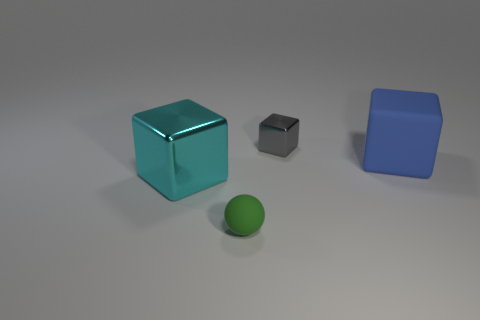Add 1 cyan blocks. How many objects exist? 5 Subtract all cubes. How many objects are left? 1 Add 1 big purple metallic things. How many big purple metallic things exist? 1 Subtract 0 red spheres. How many objects are left? 4 Subtract all green rubber balls. Subtract all gray blocks. How many objects are left? 2 Add 3 blue rubber objects. How many blue rubber objects are left? 4 